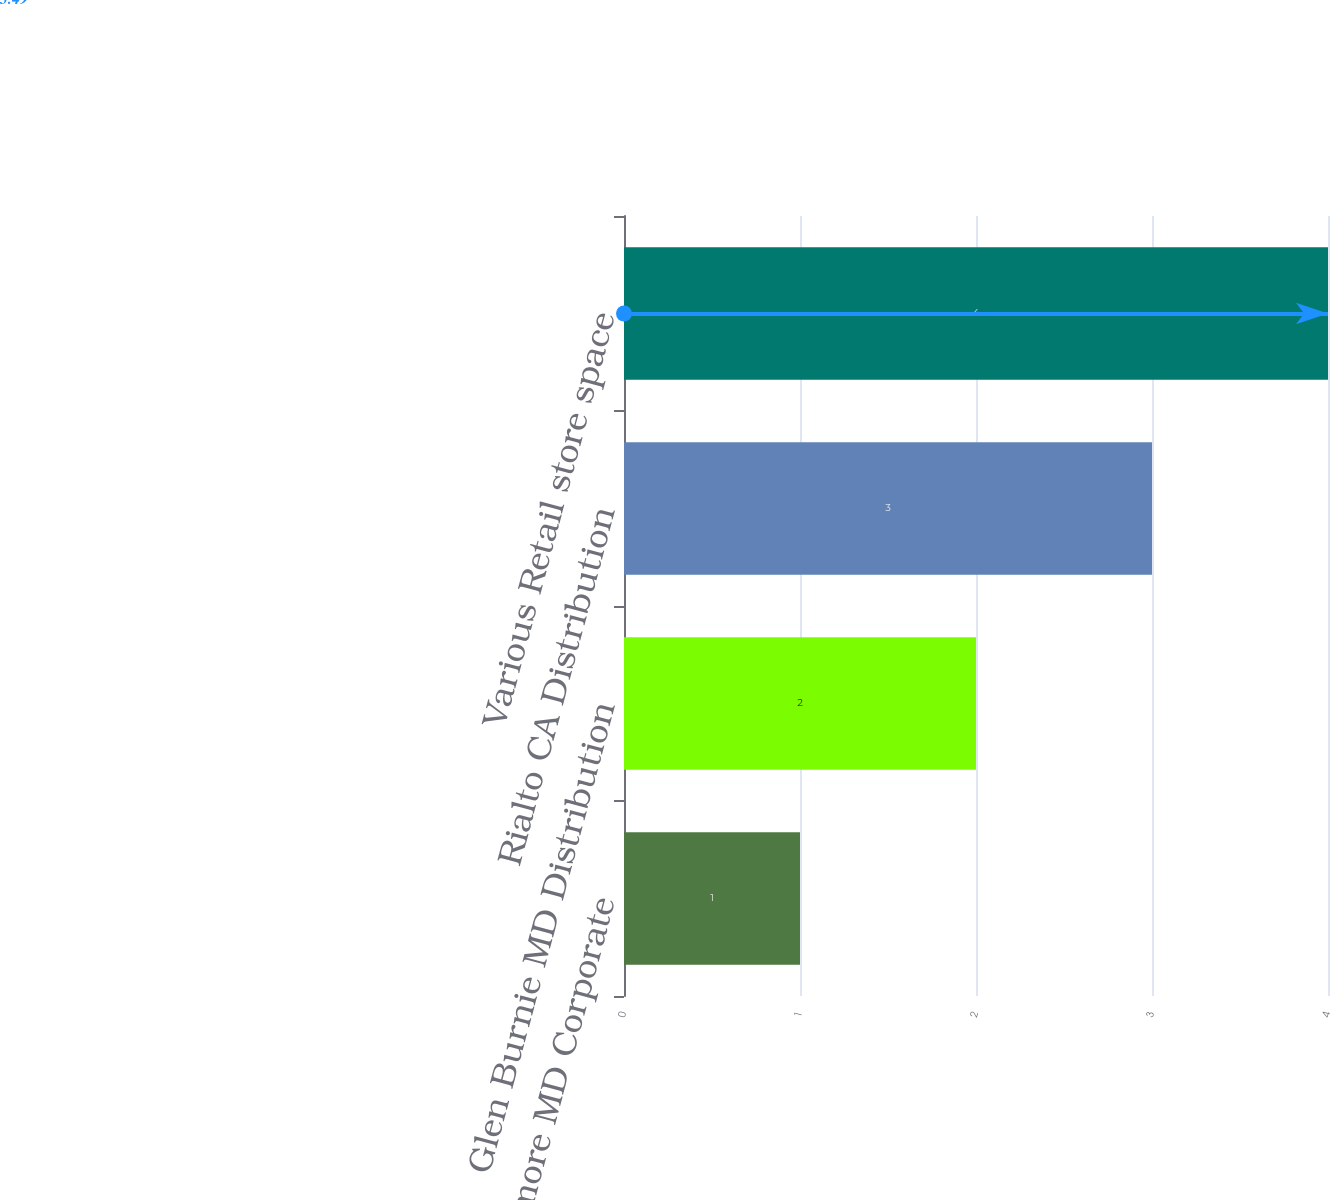<chart> <loc_0><loc_0><loc_500><loc_500><bar_chart><fcel>Baltimore MD Corporate<fcel>Glen Burnie MD Distribution<fcel>Rialto CA Distribution<fcel>Various Retail store space<nl><fcel>1<fcel>2<fcel>3<fcel>4<nl></chart> 